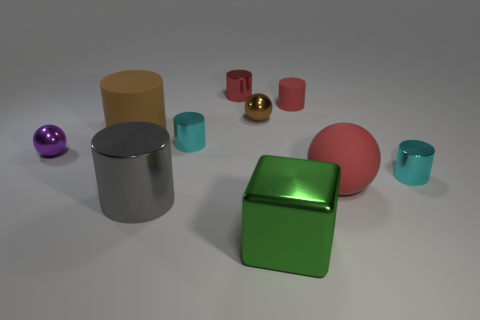Subtract all cyan cylinders. How many cylinders are left? 4 Subtract all purple blocks. How many red cylinders are left? 2 Subtract 3 cylinders. How many cylinders are left? 3 Subtract all brown cylinders. How many cylinders are left? 5 Subtract all blocks. How many objects are left? 9 Add 1 tiny cyan metallic cylinders. How many tiny cyan metallic cylinders are left? 3 Add 8 brown shiny balls. How many brown shiny balls exist? 9 Subtract 0 blue balls. How many objects are left? 10 Subtract all gray cylinders. Subtract all green cubes. How many cylinders are left? 5 Subtract all brown balls. Subtract all red metallic cylinders. How many objects are left? 8 